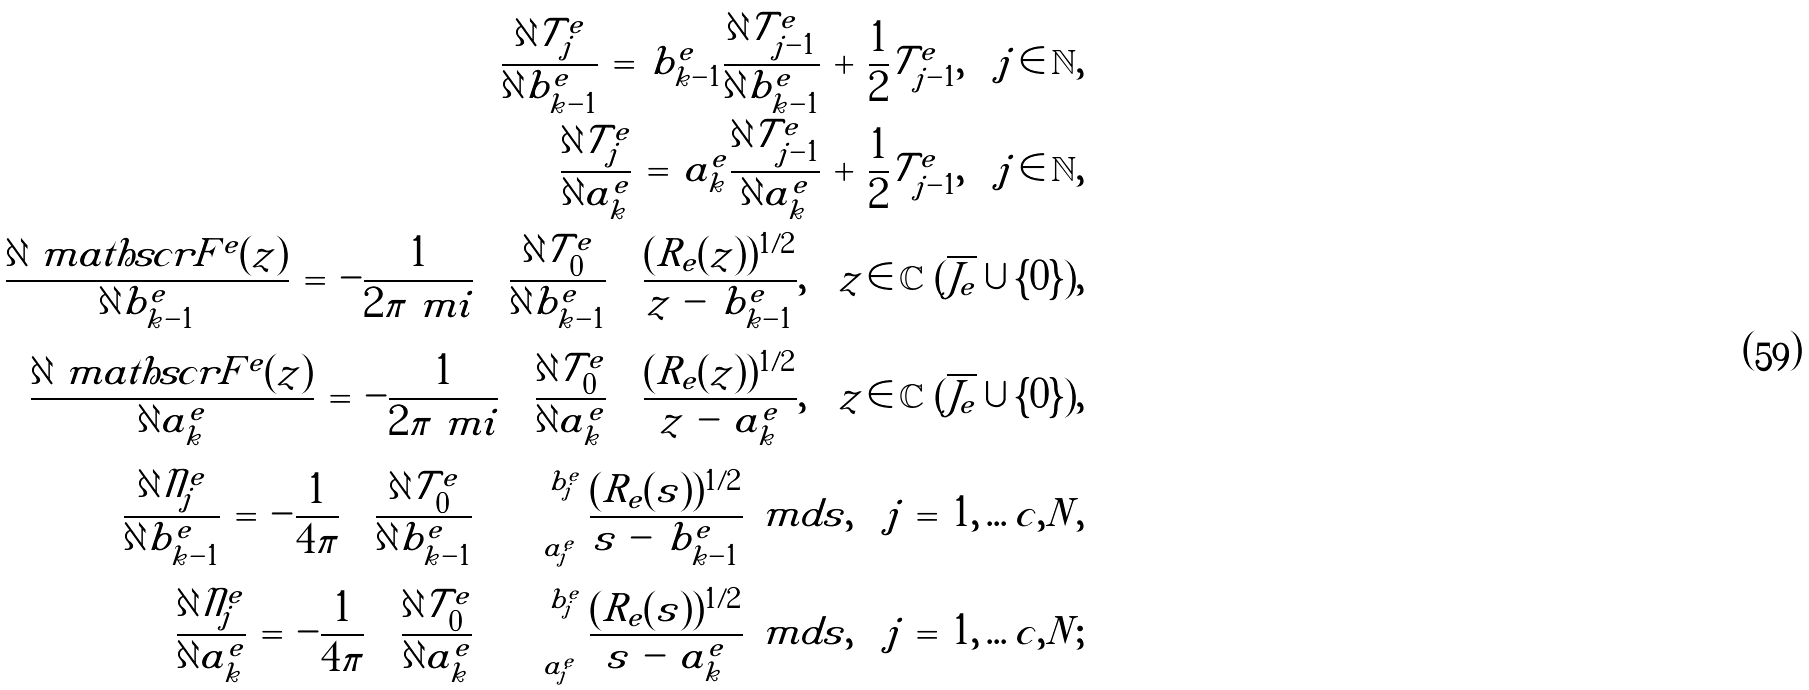<formula> <loc_0><loc_0><loc_500><loc_500>\frac { \partial \mathcal { T } _ { j } ^ { e } } { \partial b _ { k - 1 } ^ { e } } \, = \, b _ { k - 1 } ^ { e } \frac { \partial \mathcal { T } _ { j - 1 } ^ { e } } { \partial b _ { k - 1 } ^ { e } } \, + \, \frac { 1 } { 2 } \mathcal { T } _ { j - 1 } ^ { e } , \quad j \, \in \, \mathbb { N } , \\ \frac { \partial \mathcal { T } _ { j } ^ { e } } { \partial a _ { k } ^ { e } } \, = \, a _ { k } ^ { e } \frac { \partial \mathcal { T } _ { j - 1 } ^ { e } } { \partial a _ { k } ^ { e } } \, + \, \frac { 1 } { 2 } \mathcal { T } _ { j - 1 } ^ { e } , \quad j \, \in \, \mathbb { N } , \\ \frac { \partial \ m a t h s c r { F } ^ { e } ( z ) } { \partial b _ { k - 1 } ^ { e } } \, = \, - \frac { 1 } { 2 \pi \ m i } \, \left ( \frac { \partial \mathcal { T } _ { 0 } ^ { e } } { \partial b _ { k - 1 } ^ { e } } \right ) \, \frac { ( R _ { e } ( z ) ) ^ { 1 / 2 } } { z \, - \, b _ { k - 1 } ^ { e } } , \quad z \, \in \, \mathbb { C } \ ( \overline { J _ { e } } \cup \{ 0 \} ) , \\ \frac { \partial \ m a t h s c r { F } ^ { e } ( z ) } { \partial a _ { k } ^ { e } } \, = \, - \frac { 1 } { 2 \pi \ m i } \, \left ( \frac { \partial \mathcal { T } _ { 0 } ^ { e } } { \partial a _ { k } ^ { e } } \right ) \, \frac { ( R _ { e } ( z ) ) ^ { 1 / 2 } } { z \, - \, a _ { k } ^ { e } } , \quad z \, \in \, \mathbb { C } \ ( \overline { J _ { e } } \cup \{ 0 \} ) , \\ \frac { \partial \mathcal { N } _ { j } ^ { e } } { \partial b _ { k - 1 } ^ { e } } \, = \, - \frac { 1 } { 4 \pi } \, \left ( \frac { \partial \mathcal { T } _ { 0 } ^ { e } } { \partial b _ { k - 1 } ^ { e } } \right ) \, \int _ { a _ { j } ^ { e } } ^ { b _ { j } ^ { e } } \frac { ( R _ { e } ( s ) ) ^ { 1 / 2 } } { s \, - \, b _ { k - 1 } ^ { e } } \, \ m d s , \quad j \, = \, 1 , \dots c , N , \\ \frac { \partial \mathcal { N } _ { j } ^ { e } } { \partial a _ { k } ^ { e } } \, = \, - \frac { 1 } { 4 \pi } \, \left ( \frac { \partial \mathcal { T } _ { 0 } ^ { e } } { \partial a _ { k } ^ { e } } \right ) \, \int _ { a _ { j } ^ { e } } ^ { b _ { j } ^ { e } } \frac { ( R _ { e } ( s ) ) ^ { 1 / 2 } } { s \, - \, a _ { k } ^ { e } } \, \ m d s , \quad j \, = \, 1 , \dots c , N ;</formula> 